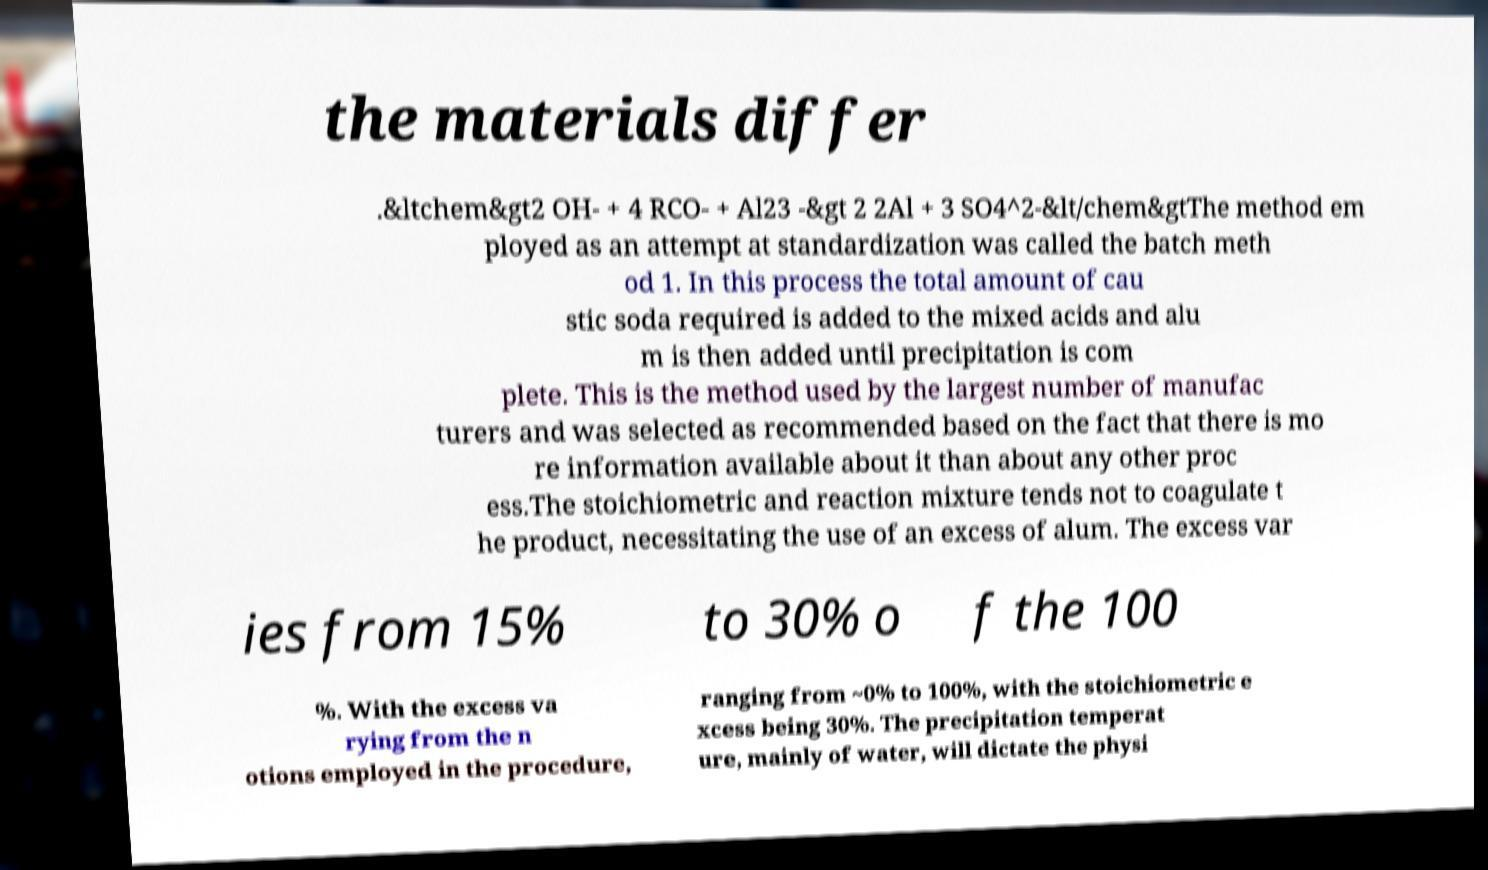I need the written content from this picture converted into text. Can you do that? the materials differ .&ltchem&gt2 OH- + 4 RCO- + Al23 -&gt 2 2Al + 3 SO4^2-&lt/chem&gtThe method em ployed as an attempt at standardization was called the batch meth od 1. In this process the total amount of cau stic soda required is added to the mixed acids and alu m is then added until precipitation is com plete. This is the method used by the largest number of manufac turers and was selected as recommended based on the fact that there is mo re information available about it than about any other proc ess.The stoichiometric and reaction mixture tends not to coagulate t he product, necessitating the use of an excess of alum. The excess var ies from 15% to 30% o f the 100 %. With the excess va rying from the n otions employed in the procedure, ranging from ~0% to 100%, with the stoichiometric e xcess being 30%. The precipitation temperat ure, mainly of water, will dictate the physi 